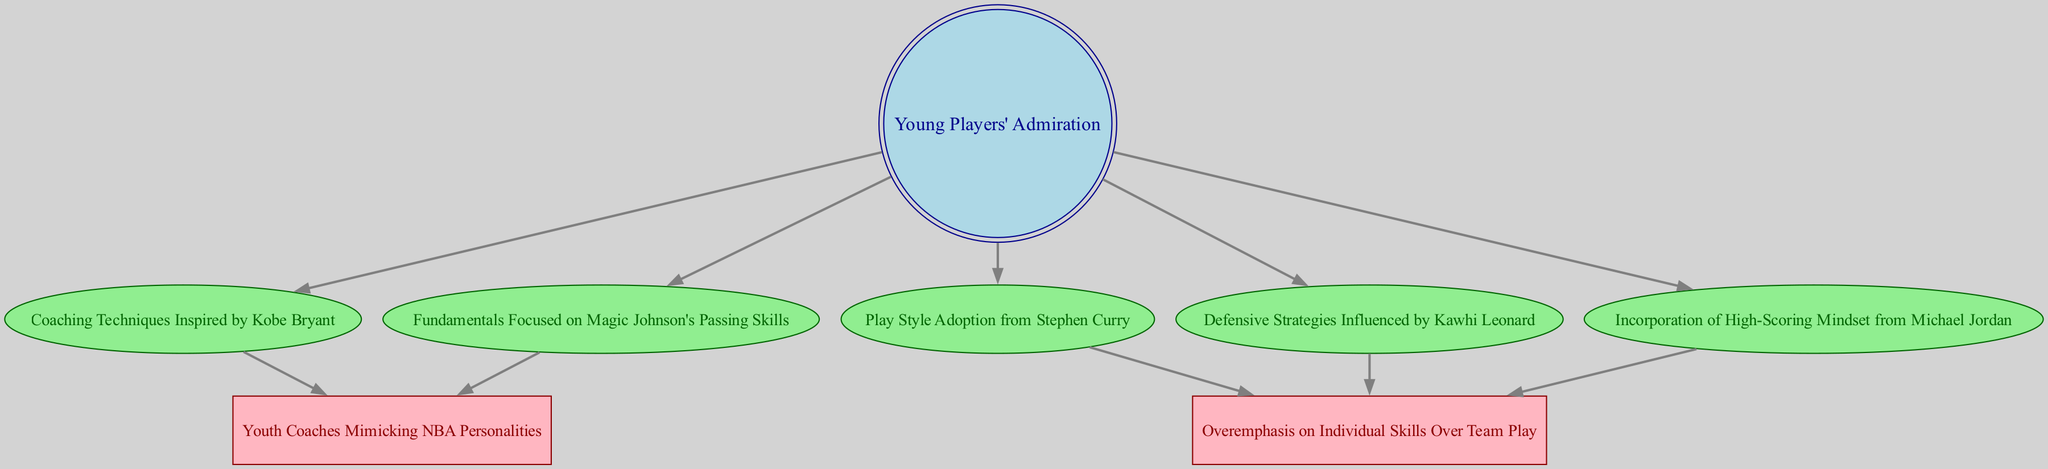What's the total number of nodes in the diagram? Counting all the nodes listed, there are eight distinct nodes represented in the diagram.
Answer: 8 Which player inspired the coaching techniques related to admiration of young players? The directed edge from "Young Players' Admiration" points to "Coaching Techniques Inspired by Kobe Bryant", indicating that Kobe Bryant is the player associated with this coaching technique.
Answer: Kobe Bryant How many edges are connected to the "Young Players' Admiration" node? By inspecting the edges attached to "Young Players' Admiration", we can see that there are five edges leading out from this node, demonstrating connections to various coaching influences.
Answer: 5 Which two coaching styles are influenced by "Youth Coaches Mimicking NBA Personalities"? The edges from "Coaching Techniques Inspired by Kobe Bryant" and "Fundamentals Focused on Magic Johnson's Passing Skills" both point to "Youth Coaches Mimicking NBA Personalities", indicating these two coaching styles influence this node.
Answer: Kobe Bryant and Magic Johnson What is the relationship between "High-Scoring Mindset from Michael Jordan" and team play? The edge from "High-Scoring Mindset from Michael Jordan" to "Overemphasis on Individual Skills Over Team Play" suggests that the mindset inspired by Jordan has a tendency to shift focus from team play to individual skills, indicating a potential negative impact on team dynamics.
Answer: Individual skills over team play Which player's influence leads to defensive strategies that overemphasize individual skills? There is a direct connection from "Defensive Strategies Influenced by Kawhi Leonard" to "Overemphasis on Individual Skills Over Team Play", showing that his influence is associated with this emphasis on individual play.
Answer: Kawhi Leonard How many players are directly associated with a focus on youth coaching as represented in the nodes? By examining the nodes leading to "Youth Coaches Mimicking NBA Personalities", there are three players listed that influence youth coaching: Kobe Bryant, Magic Johnson, and Stephen Curry, suggesting a collective impact on coaching styles.
Answer: 3 What style of play is directly adopted from Stephen Curry? The edge from "Young Players' Admiration" to "Play Style Adoption from Stephen Curry" explicitly indicates the type of play that young players admire and adopt, which is uniquely associated with Stephen Curry's style.
Answer: Play Style Adoption from Stephen Curry What concept does "Fundamentals Focused on Magic Johnson's Passing Skills" represent in coaching? This node represents the focus that youth coaches may adopt in teaching essential basketball skills such as passing, directly inspired by Magic Johnson, which emphasizes foundational skills in basketball coaching.
Answer: Fundamentals of passing skills 